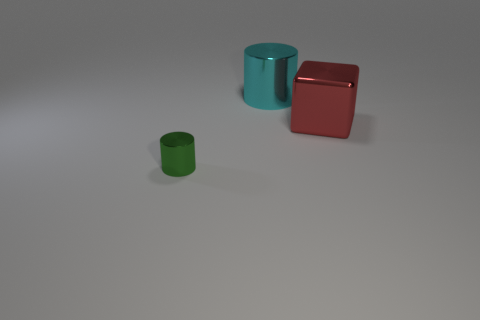Add 1 red shiny objects. How many objects exist? 4 Subtract all cyan cylinders. How many cylinders are left? 1 Subtract all cylinders. How many objects are left? 1 Subtract all gray blocks. How many green cylinders are left? 1 Subtract all cyan metal cylinders. Subtract all big red rubber blocks. How many objects are left? 2 Add 2 tiny objects. How many tiny objects are left? 3 Add 1 red matte things. How many red matte things exist? 1 Subtract 0 gray spheres. How many objects are left? 3 Subtract 2 cylinders. How many cylinders are left? 0 Subtract all blue blocks. Subtract all red cylinders. How many blocks are left? 1 